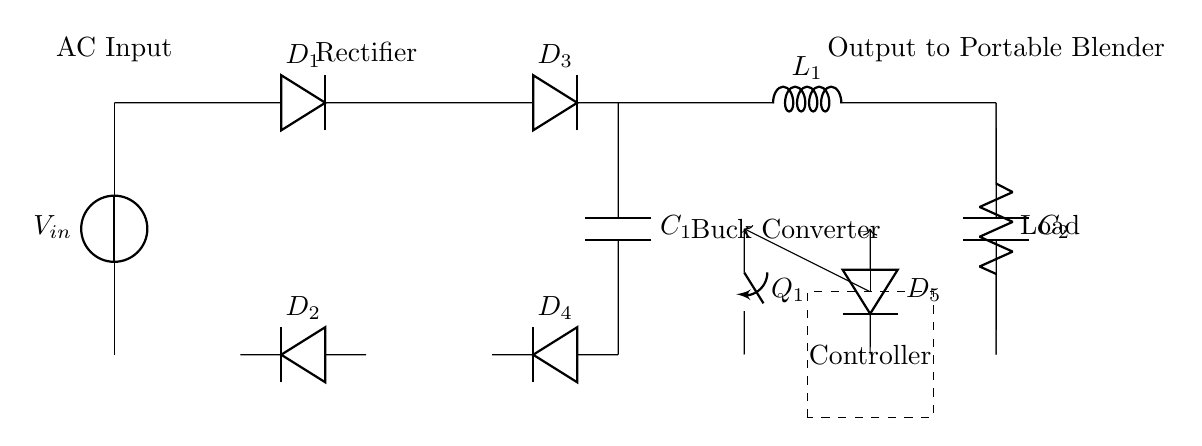What is the input source voltage of this circuit? The circuit diagram indicates an input voltage source labeled as V_{in} at the top left, which is the starting point of the circuit.
Answer: V_{in} What type of component is labeled D₁? The component D₁ in the circuit diagram is labeled as a diode. Diodes are indicated by a triangle symbol with a vertical line and it is used to allow current to flow in one direction.
Answer: Diode How many capacitors are present in this circuit? In the circuit diagram, two capacitors are labeled: C₁ and C₂, which are indicated by the C symbol. Therefore, there are two capacitors present.
Answer: 2 What is the purpose of the buck converter in this circuit? The buck converter, depicted between the rectifier and the load, is responsible for stepping down the voltage. It is a crucial part of the circuit, ensuring that the output voltage is lower than the input voltage for compatible operation with the blender or juicer.
Answer: Steps down voltage What does the dashed rectangle labeled "Controller" signify? The dashed rectangle labeled "Controller" represents a device or component that regulates or controls the conversion process, such as controlling the switch Q₁ and managing the output voltage. This component is essential for maintaining the desired performance of the circuit.
Answer: Regulation device What is the output of the circuit intended for? The output terminal of the circuit is indicated with the label "Output to Portable Blender," which signifies that the circuit is designed to provide power to a portable blender or juicer, specifically for nutrition demonstrations.
Answer: Portable blender What type of rectification is performed in this circuit? The circuit diagram includes four diodes arranged, which suggests it is using a full-wave rectification design. This allows both halves of the AC signal to be utilized, providing a more stable DC output.
Answer: Full-wave rectification 